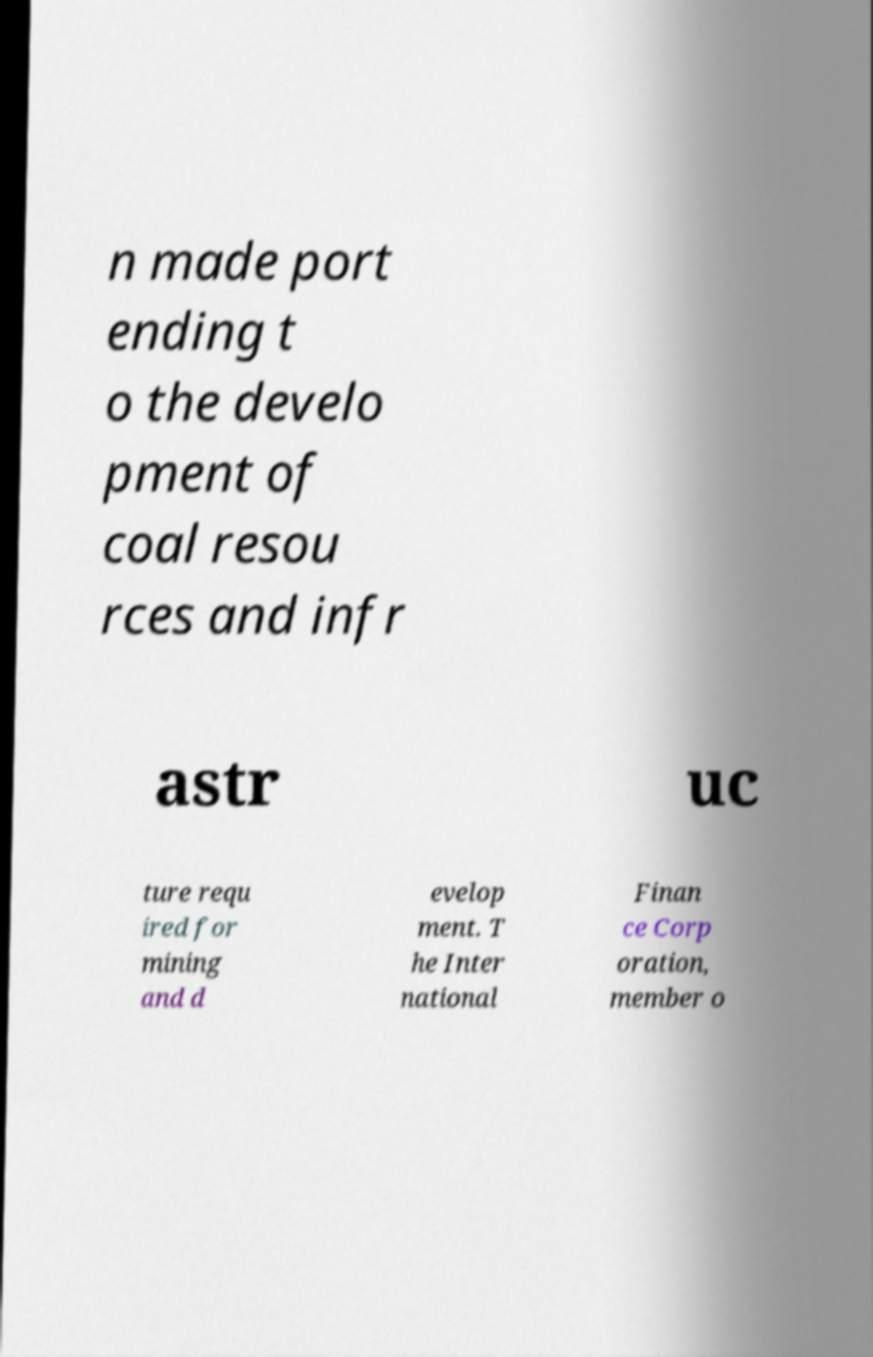For documentation purposes, I need the text within this image transcribed. Could you provide that? n made port ending t o the develo pment of coal resou rces and infr astr uc ture requ ired for mining and d evelop ment. T he Inter national Finan ce Corp oration, member o 